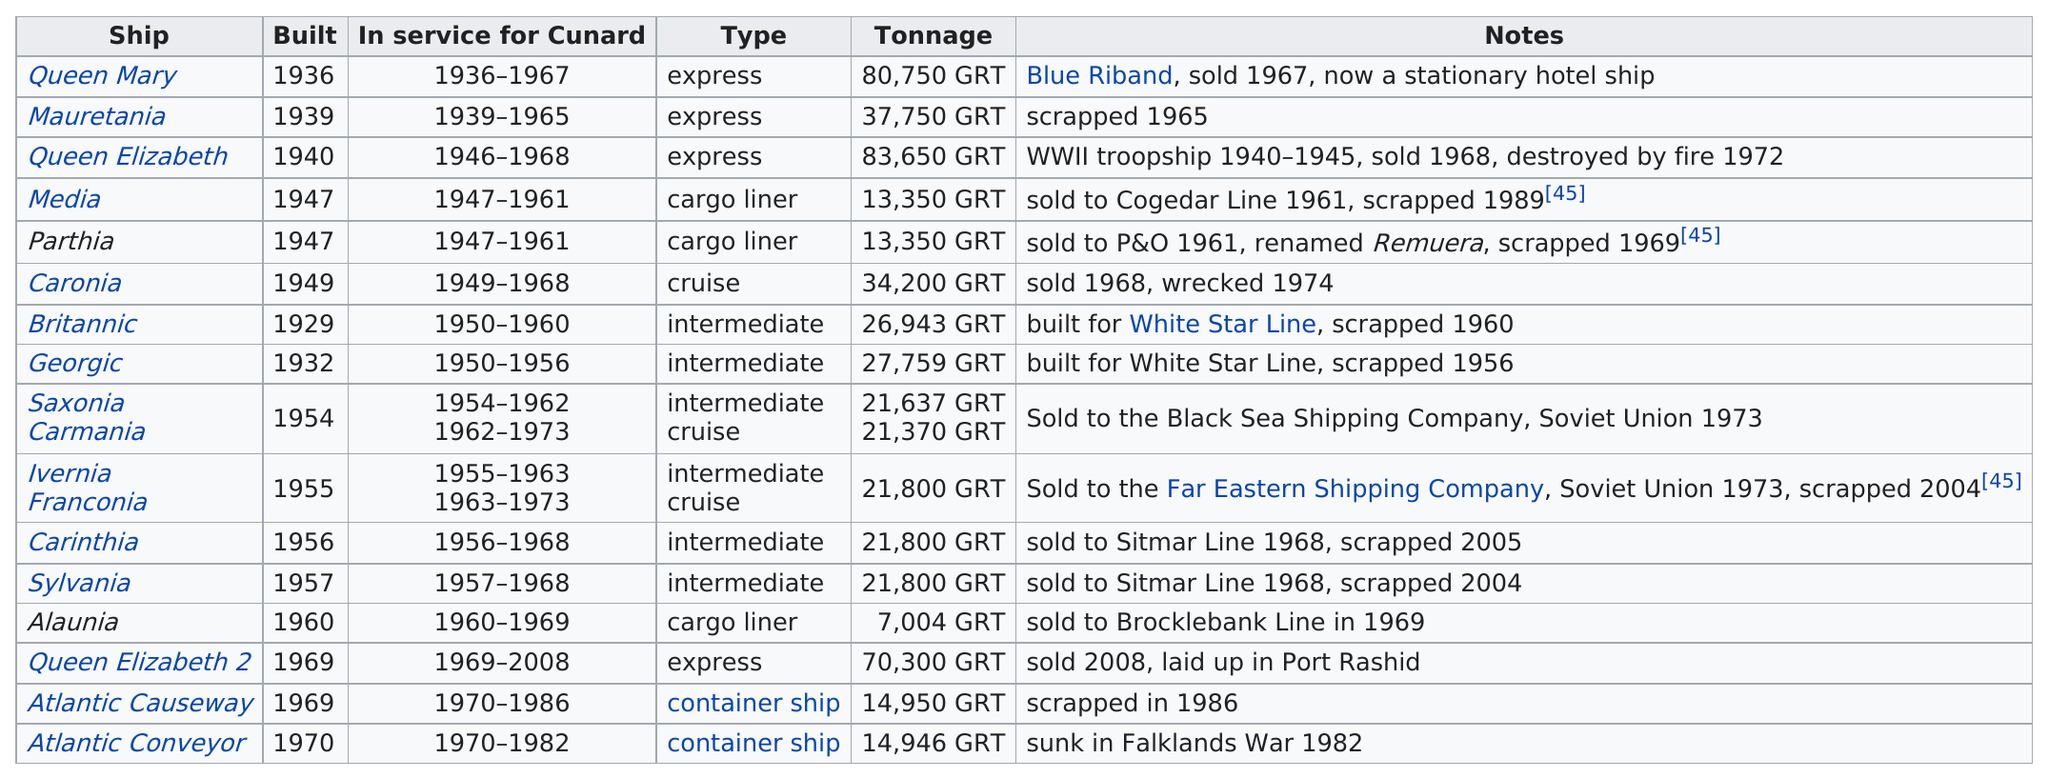Indicate a few pertinent items in this graphic. The White Star Line built two ships, the Britannic and the Georgic, both of which were designed for the purpose of transporting passengers and cargo. The ship with the most tonnage is named after Queen Elizabeth. The Queen Elizabeth was the first troopship employed during World War II. The ship with the least years in service among Cunard is the Georgic with 10 years. The last ship was built in 1970. 